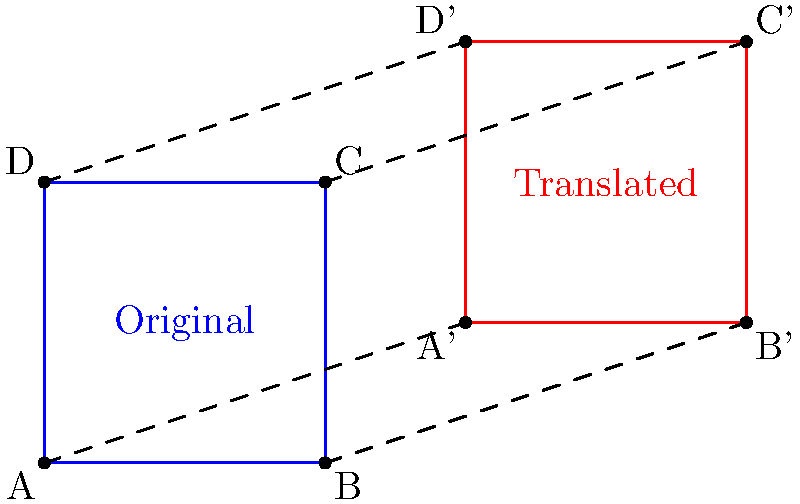In the picture, we see a blue square that has been translated (slid) to become the red square. How far did the square move to the right, and how far did it move up? Let's follow these steps to find out how the square moved:

1. Look at point A (bottom-left corner of the blue square) and point A' (bottom-left corner of the red square).

2. To find how far the square moved right:
   - A is at x = 0
   - A' is at x = 3
   - The difference is 3 - 0 = 3 units to the right

3. To find how far the square moved up:
   - A is at y = 0
   - A' is at y = 1
   - The difference is 1 - 0 = 1 unit up

4. We can check this with the other corners too. For example, B to B' also moves 3 units right and 1 unit up.

So, the square has been translated 3 units to the right and 1 unit up.
Answer: 3 units right, 1 unit up 